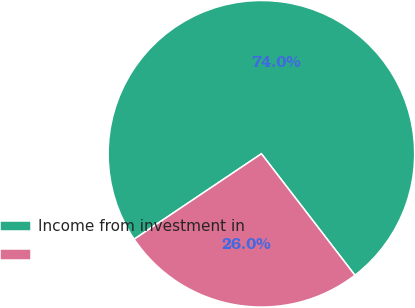<chart> <loc_0><loc_0><loc_500><loc_500><pie_chart><fcel>Income from investment in<fcel>Unnamed: 1<nl><fcel>73.97%<fcel>26.03%<nl></chart> 